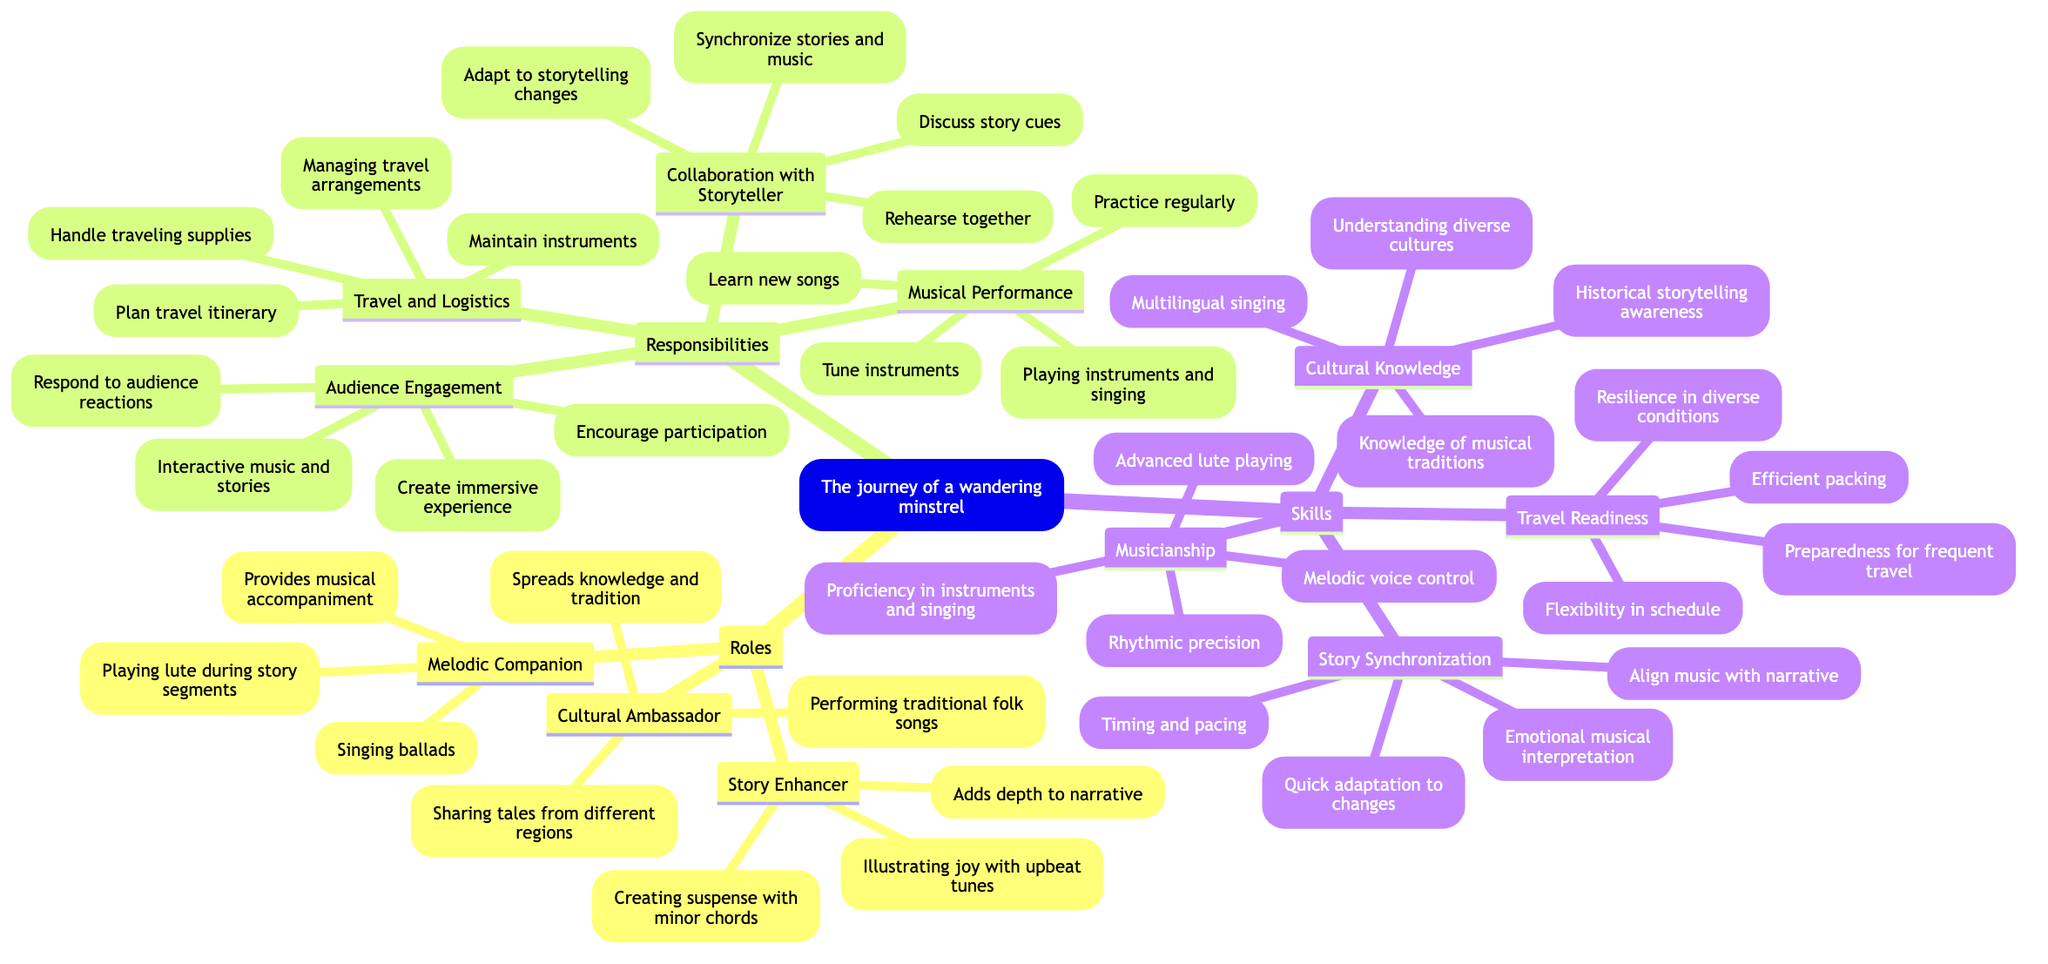What role encompasses providing musical accompaniment? The diagram specifies that the role of "Melodic Companion" includes providing musical accompaniment to enhance storytelling. This node directly addresses the function and describes it within its context.
Answer: Melodic Companion How many responsibilities does a wandering minstrel have? In the diagram, there are four distinct responsibilities listed: Musical Performance, Collaboration with Storyteller, Audience Engagement, and Travel and Logistics. By counting these nodes, we find the total number of responsibilities.
Answer: 4 What is one example of a task under "Audience Engagement"? The diagram lists "Encourage audience participation" as a task under the responsibility of "Audience Engagement." This task directly represents how the minstrel interacts with the audience.
Answer: Encourage audience participation Which skill involves proficiency in playing instruments? The diagram identifies "Musicianship" as the skill that covers proficiency in playing musical instruments and singing. This information is clearly stated under the skills section.
Answer: Musicianship What responsibilities are involved in managing travel arrangements? "Travel and Logistics" pertains to managing travel arrangements, which includes planning the itinerary and maintaining instruments. These elements are part of one of the responsibilities assigned to a minstrel.
Answer: Travel and Logistics How does a minstrel engage with storytelling? The minstrel's engagement with storytelling is primarily through "Collaboration with Storyteller," which entails rehearsing together and discussing story cues. This relationship emphasizes their role in synchronizing music with narratives.
Answer: Collaboration with Storyteller What is a skill related to understanding diverse cultures? The skill known as "Cultural Knowledge" encompasses understanding and incorporating various cultural elements. This node explicitly focuses on the minstrel's ability to weave cultural aspects into their performance.
Answer: Cultural Knowledge Which two roles focus on enhancing the storytelling experience? "Melodic Companion" and "Story Enhancer" are two roles that focus on enhancing storytelling. Each of these roles contributes differently: one through musical accompaniment and the other through depth and emotional engagement.
Answer: Melodic Companion, Story Enhancer Name a task related to practicing music. Under "Musical Performance," the task "Practice regularly" emphasizes the essential act of honing one's musical skills as part of the minstrel's responsibilities. This task emphasizes continuous improvement in performance.
Answer: Practice regularly 